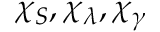<formula> <loc_0><loc_0><loc_500><loc_500>\chi _ { S } , \chi _ { \lambda } , \chi _ { \gamma }</formula> 